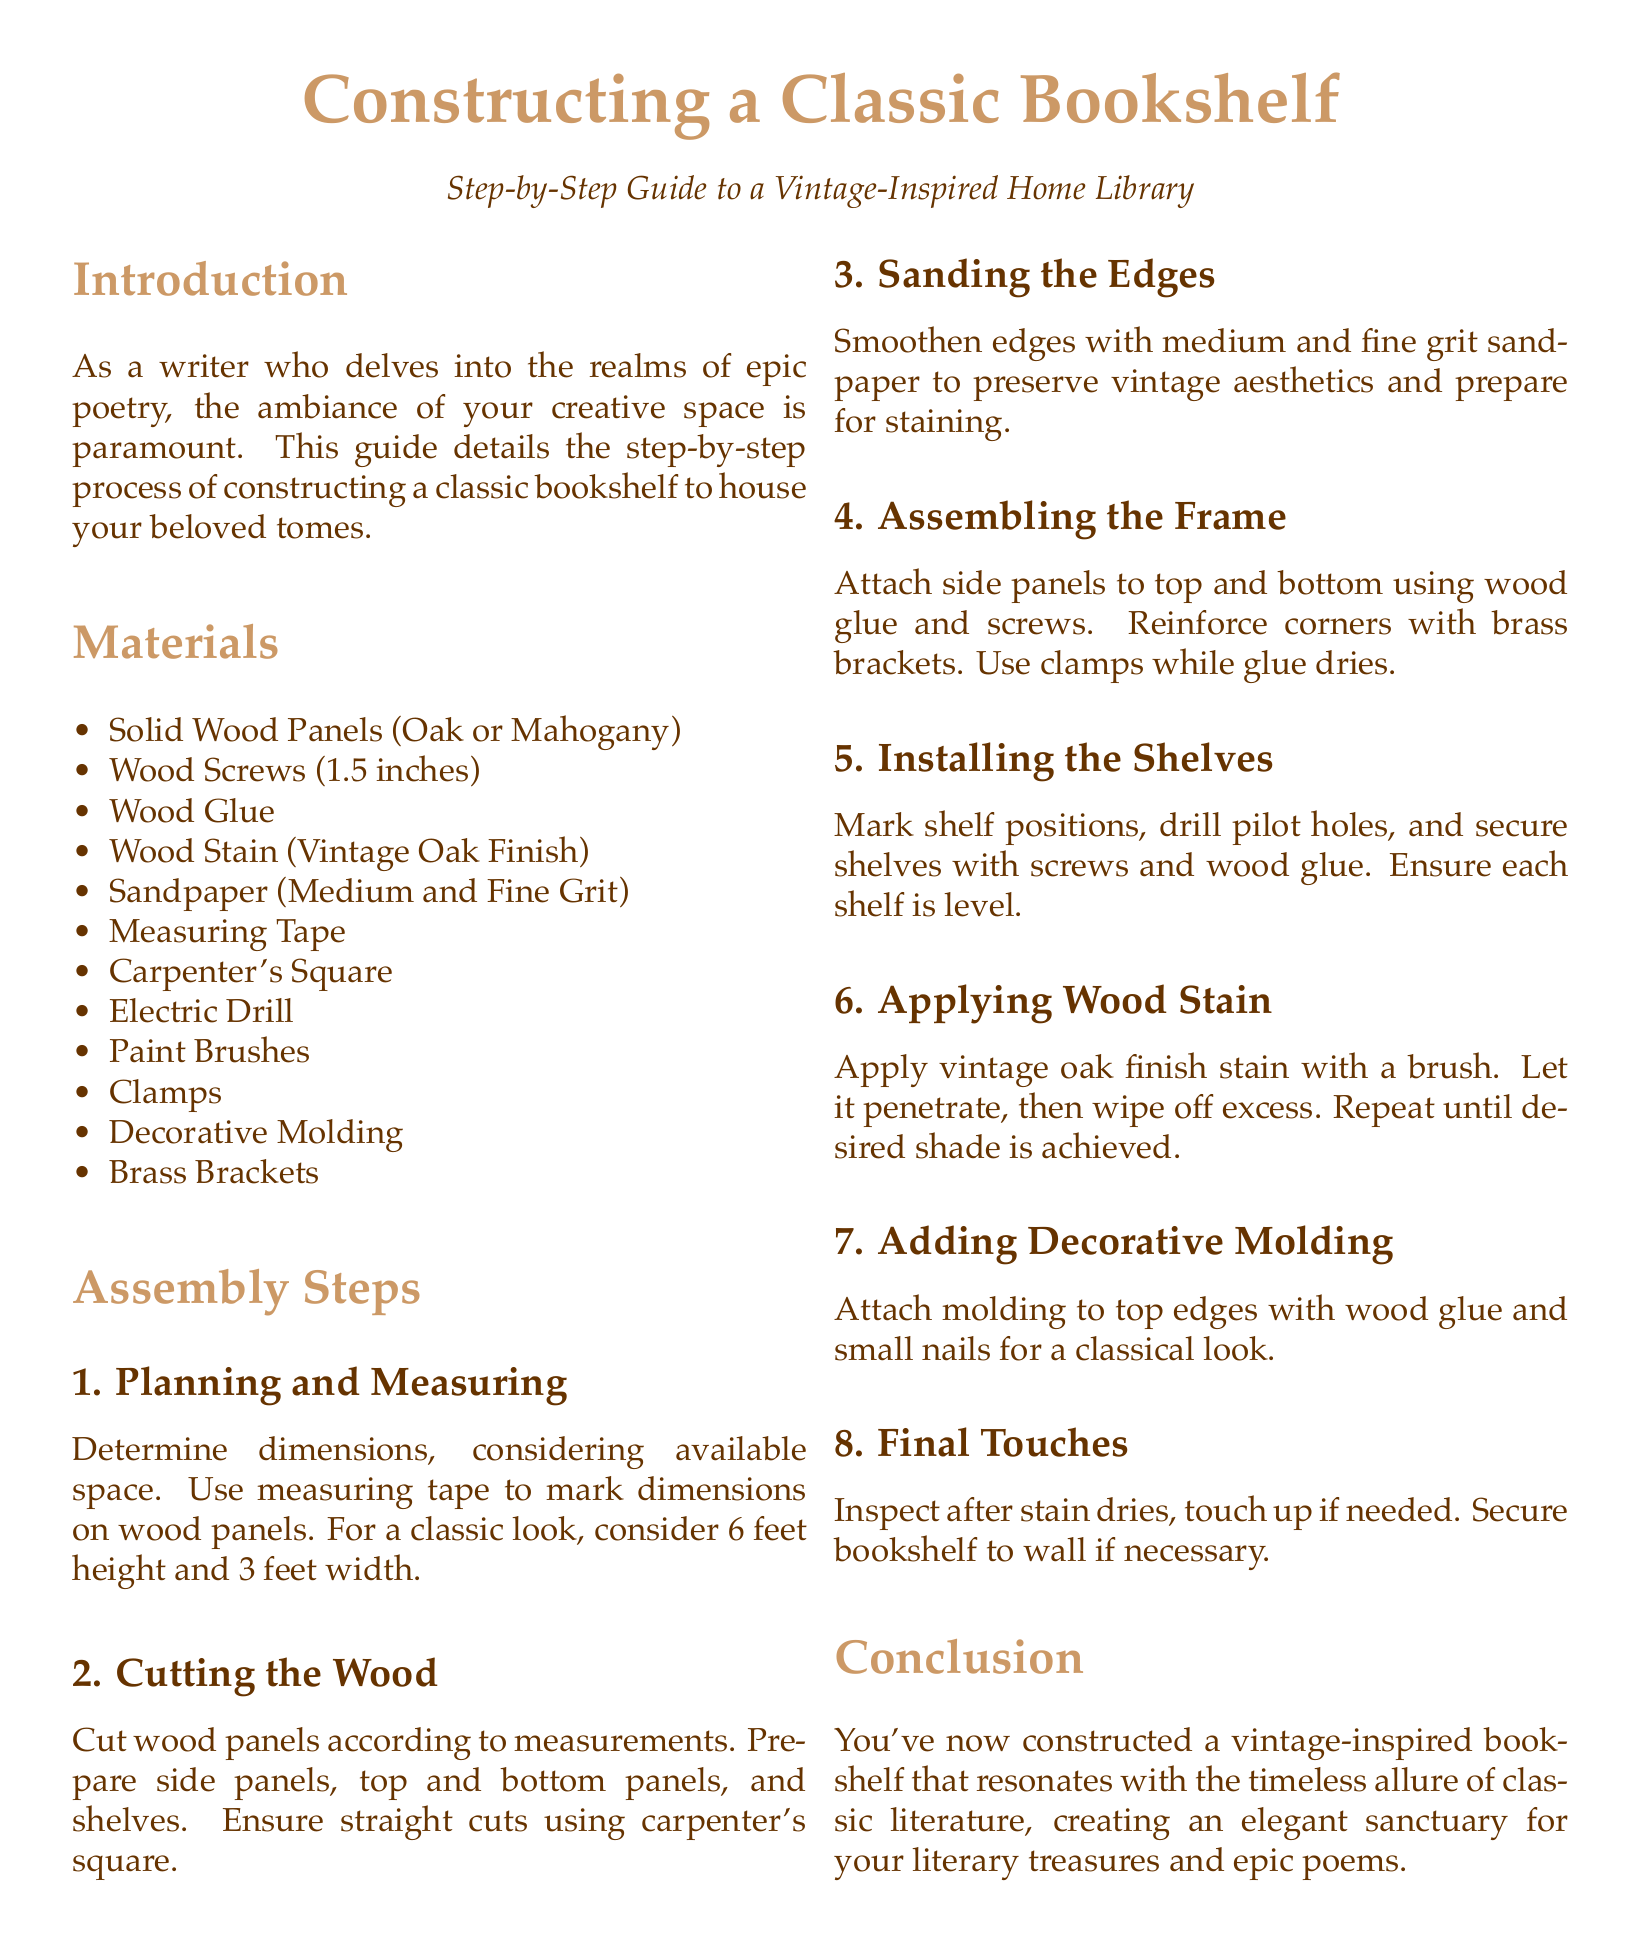What type of wood is recommended for the bookshelf? The document lists solid wood panels such as oak or mahogany as suitable materials for the bookshelf.
Answer: Oak or Mahogany How many inches are the wood screws? The instructions specify using wood screws that are 1.5 inches in length for the assembly of the bookshelf.
Answer: 1.5 inches What is the height suggested for the bookshelf? The document recommends a height of 6 feet for a classic look when planning the bookshelf dimensions.
Answer: 6 feet What is the final step after applying wood stain? The last specified step in the assembly process is to inspect the bookshelf after the stain dries and touch up if necessary.
Answer: Touch up if needed How many total assembly steps are there? The document outlines a total of 8 assembly steps necessary to construct the classic bookshelf.
Answer: 8 steps What tool is used to ensure straight cuts? The instructions recommend using a carpenter's square to ensure straight cuts during the wood cutting process.
Answer: Carpenter's Square What is used to reinforce corners during assembly? Brass brackets are advised for reinforcing corners when attaching the side panels to the top and bottom of the bookshelf.
Answer: Brass Brackets What finish is suggested for staining the wood? The instructions specify using a vintage oak finish stain for applying to the wood surfaces of the bookshelf.
Answer: Vintage Oak Finish 